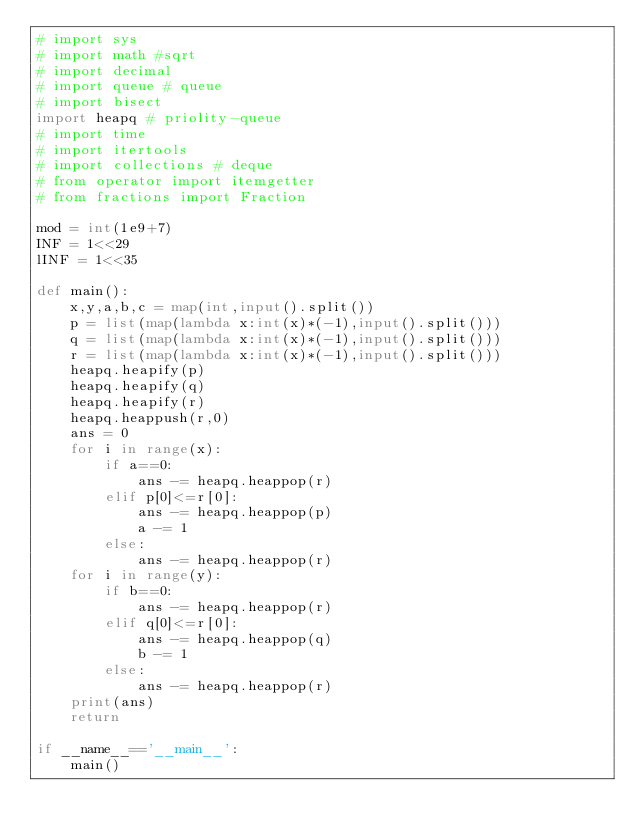Convert code to text. <code><loc_0><loc_0><loc_500><loc_500><_Python_># import sys
# import math #sqrt
# import decimal
# import queue # queue
# import bisect
import heapq # priolity-queue
# import time
# import itertools
# import collections # deque
# from operator import itemgetter
# from fractions import Fraction

mod = int(1e9+7)
INF = 1<<29
lINF = 1<<35

def main():
    x,y,a,b,c = map(int,input().split())
    p = list(map(lambda x:int(x)*(-1),input().split()))
    q = list(map(lambda x:int(x)*(-1),input().split()))
    r = list(map(lambda x:int(x)*(-1),input().split()))
    heapq.heapify(p)
    heapq.heapify(q)
    heapq.heapify(r)
    heapq.heappush(r,0)
    ans = 0
    for i in range(x):
        if a==0:
            ans -= heapq.heappop(r)
        elif p[0]<=r[0]:
            ans -= heapq.heappop(p)
            a -= 1
        else:
            ans -= heapq.heappop(r)
    for i in range(y):
        if b==0:
            ans -= heapq.heappop(r)
        elif q[0]<=r[0]:
            ans -= heapq.heappop(q)
            b -= 1
        else:
            ans -= heapq.heappop(r)
    print(ans)
    return

if __name__=='__main__':
    main()</code> 